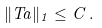Convert formula to latex. <formula><loc_0><loc_0><loc_500><loc_500>\| T a \| _ { 1 } \leq C \, .</formula> 